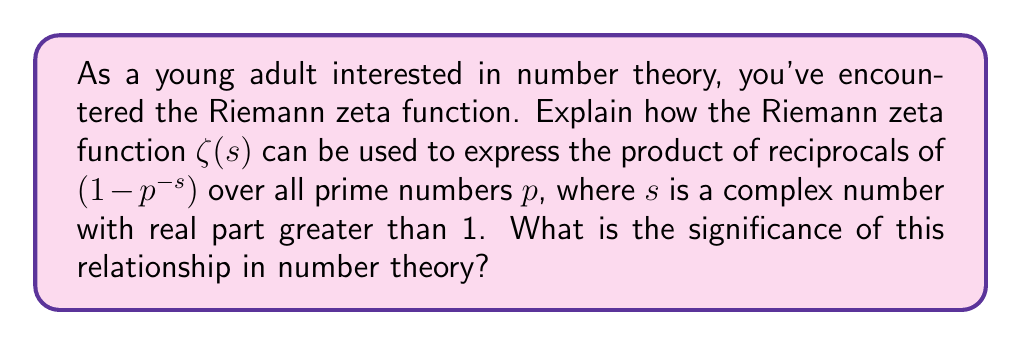Can you solve this math problem? To understand this relationship, let's break it down step by step:

1) The Riemann zeta function is defined for complex $s$ with $\text{Re}(s) > 1$ as:

   $$\zeta(s) = \sum_{n=1}^{\infty} \frac{1}{n^s}$$

2) There's a remarkable identity known as the Euler product formula, which relates the zeta function to prime numbers:

   $$\zeta(s) = \prod_{p \text{ prime}} \frac{1}{1-p^{-s}}$$

3) To prove this, we can expand each term in the product:

   $$\frac{1}{1-p^{-s}} = 1 + p^{-s} + p^{-2s} + p^{-3s} + ...$$

4) When we multiply these expansions for all primes, we get all possible products of prime powers, which generate all positive integers uniquely (by the fundamental theorem of arithmetic).

5) The significance of this relationship is profound:
   - It provides a direct link between the zeta function and prime numbers.
   - It shows that information about the distribution of primes is encoded in the analytic properties of $\zeta(s)$.
   - The zeros of $\zeta(s)$ are crucial in understanding the distribution of primes (Riemann Hypothesis).

6) This connection allows number theorists to use complex analysis techniques to study prime numbers, leading to powerful results like the Prime Number Theorem.

7) The Riemann Hypothesis, which concerns the zeros of $\zeta(s)$, is considered one of the most important unsolved problems in mathematics, with implications for the distribution of primes.
Answer: The Riemann zeta function $\zeta(s)$ can be expressed as the product $\prod_{p \text{ prime}} \frac{1}{1-p^{-s}}$ for $\text{Re}(s) > 1$. This relationship, known as the Euler product formula, establishes a fundamental connection between the zeta function and prime numbers, allowing complex analysis techniques to be applied to the study of prime number distribution in number theory. 